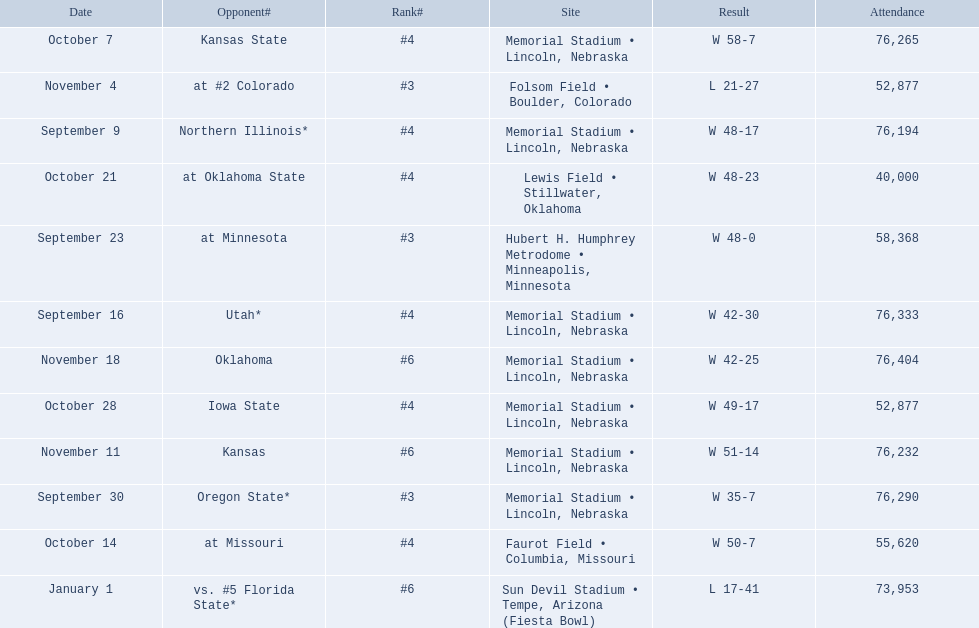When did nebraska play oregon state? September 30. What was the attendance at the september 30 game? 76,290. 